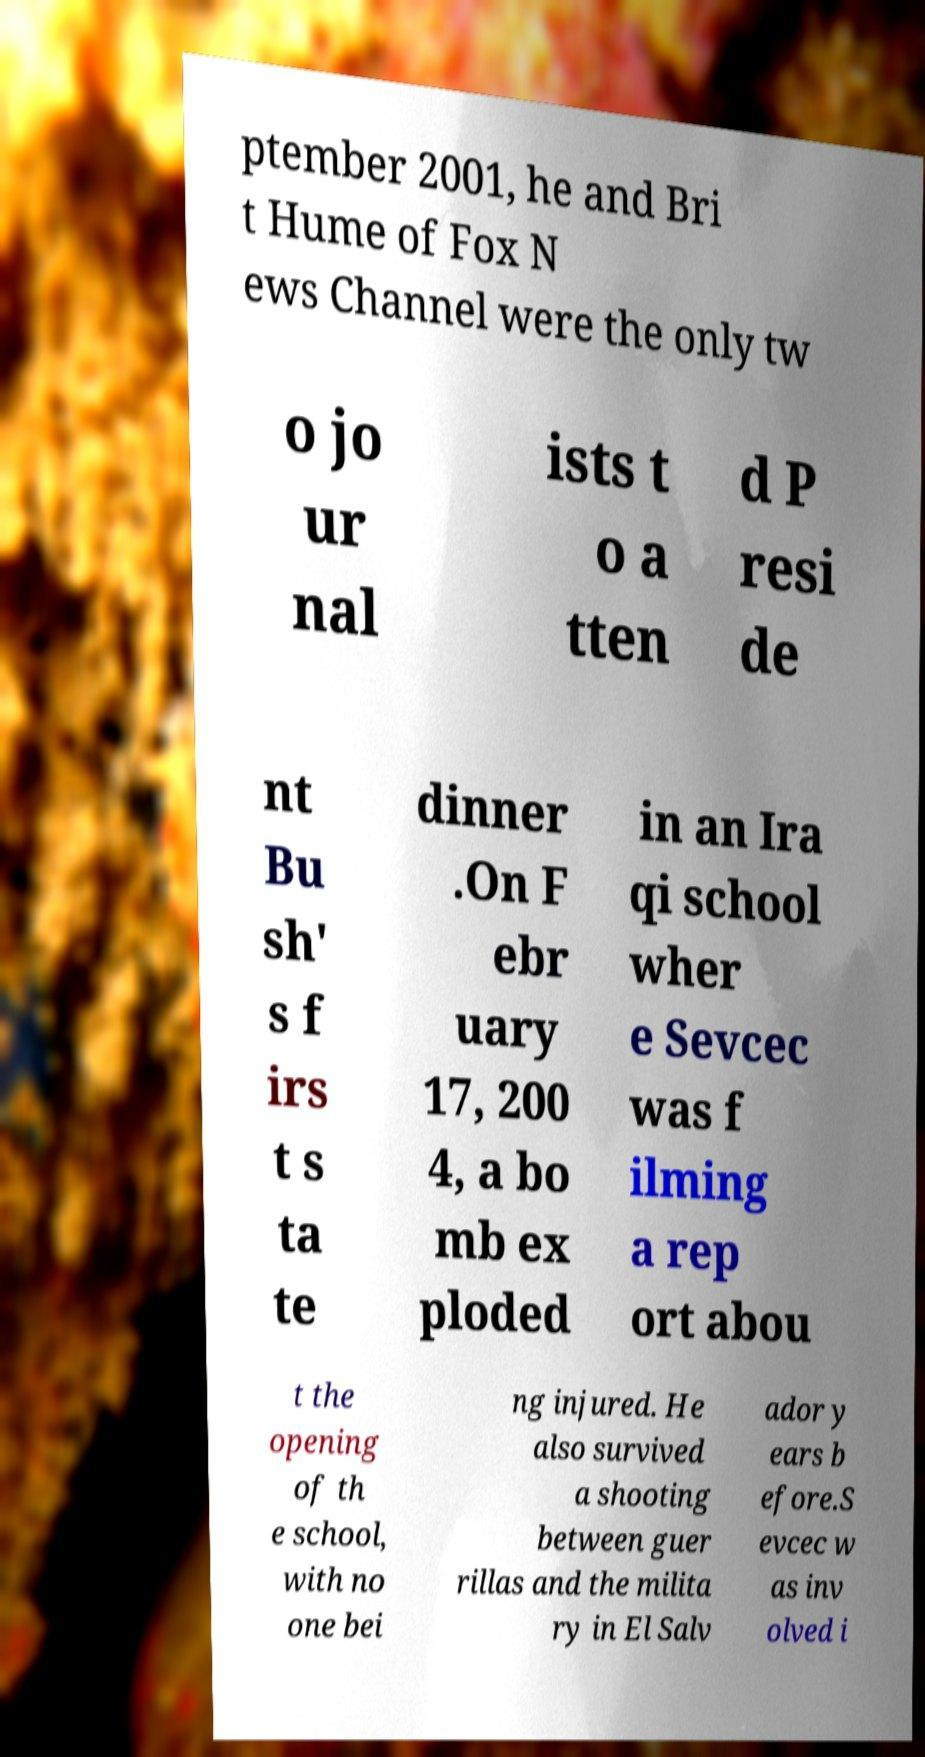Can you read and provide the text displayed in the image?This photo seems to have some interesting text. Can you extract and type it out for me? ptember 2001, he and Bri t Hume of Fox N ews Channel were the only tw o jo ur nal ists t o a tten d P resi de nt Bu sh' s f irs t s ta te dinner .On F ebr uary 17, 200 4, a bo mb ex ploded in an Ira qi school wher e Sevcec was f ilming a rep ort abou t the opening of th e school, with no one bei ng injured. He also survived a shooting between guer rillas and the milita ry in El Salv ador y ears b efore.S evcec w as inv olved i 